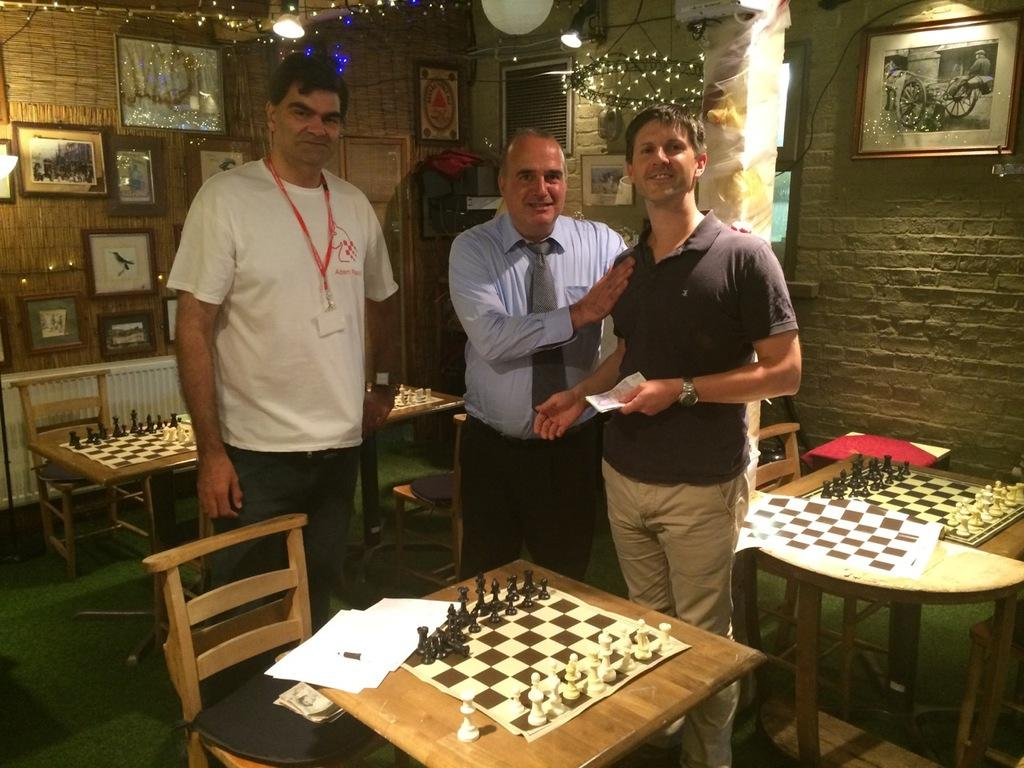How many people are in the image? There are three persons in the image. What are the persons doing in the image? The persons are standing. What objects can be seen on the table in the image? There are chess boards in the image. What is attached to the wall at the top of the image? There are sceneries attached to the wall. Can you see a pet playing with a river in the image? There is no pet or river present in the image. 